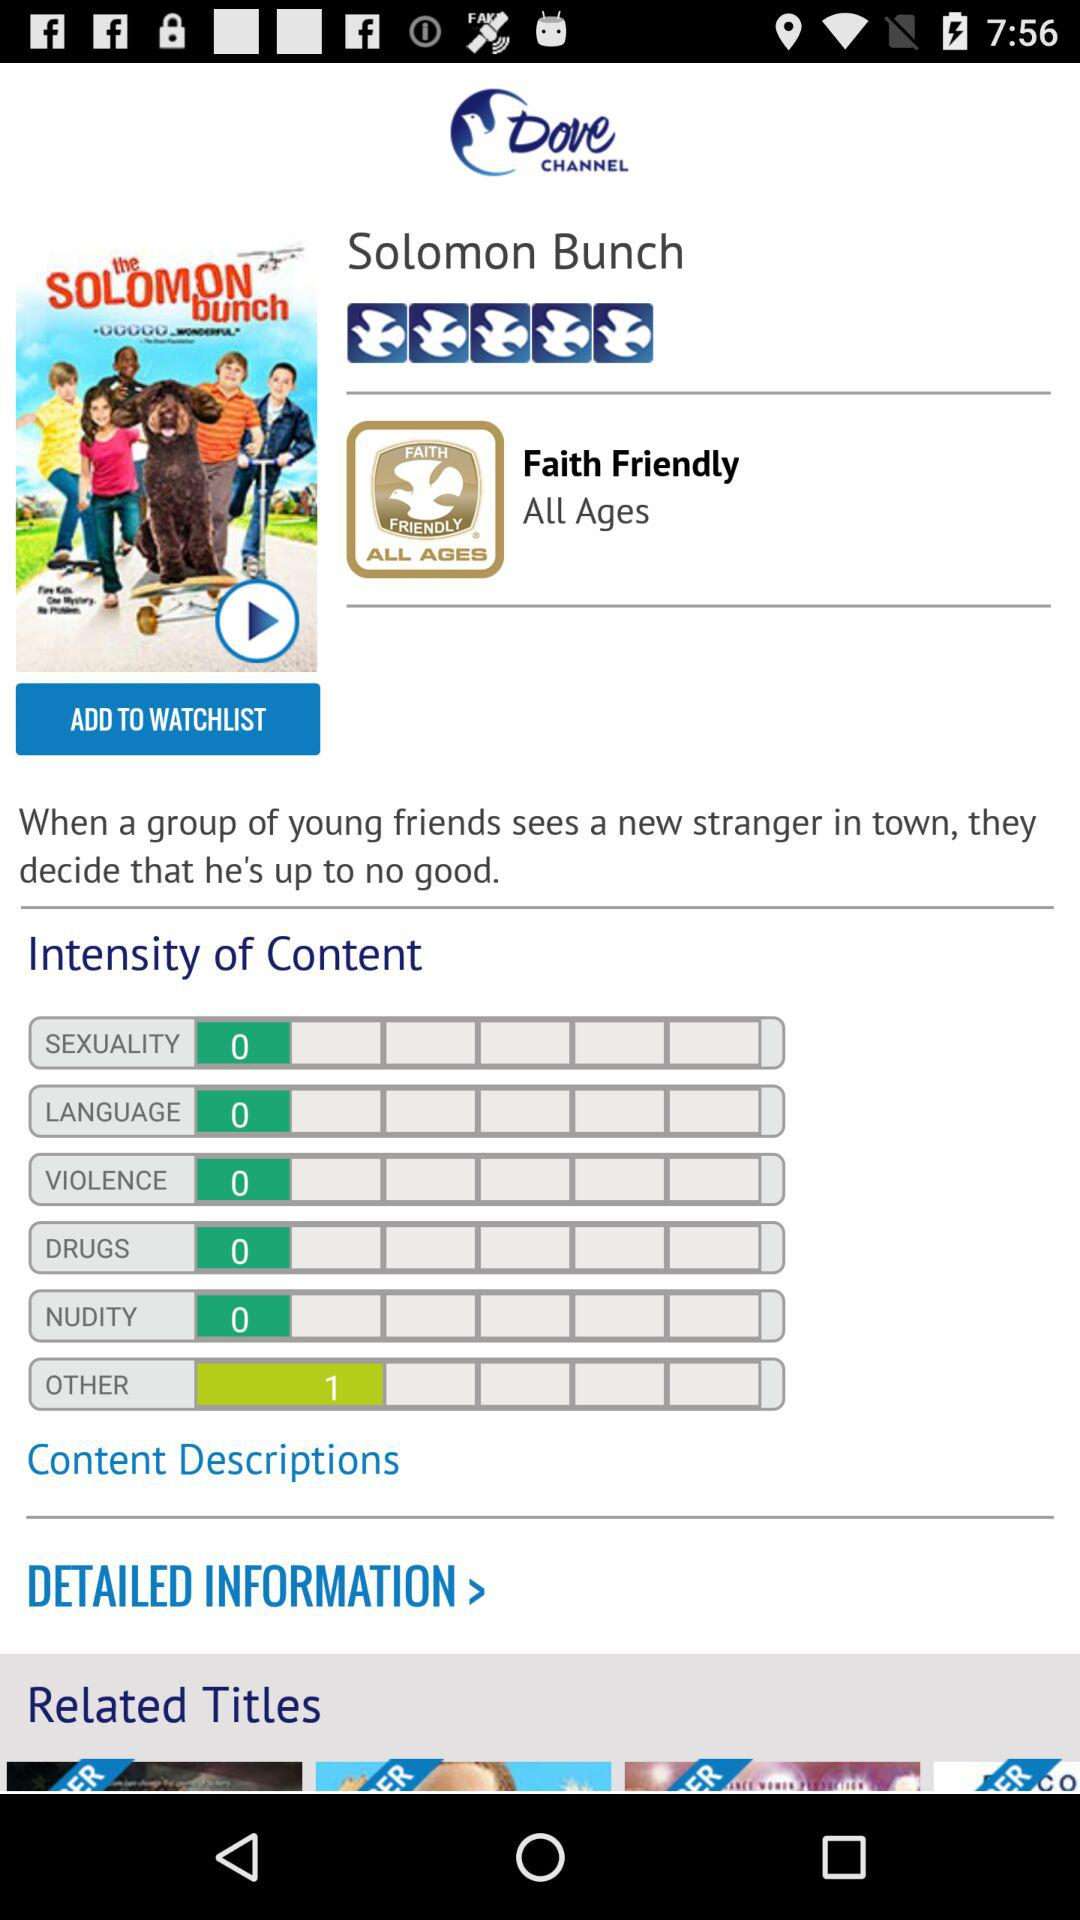What is the rating for "Other" in "Intensity of Content"? The rating is 1 for "Other" in "Intensity of Content". 